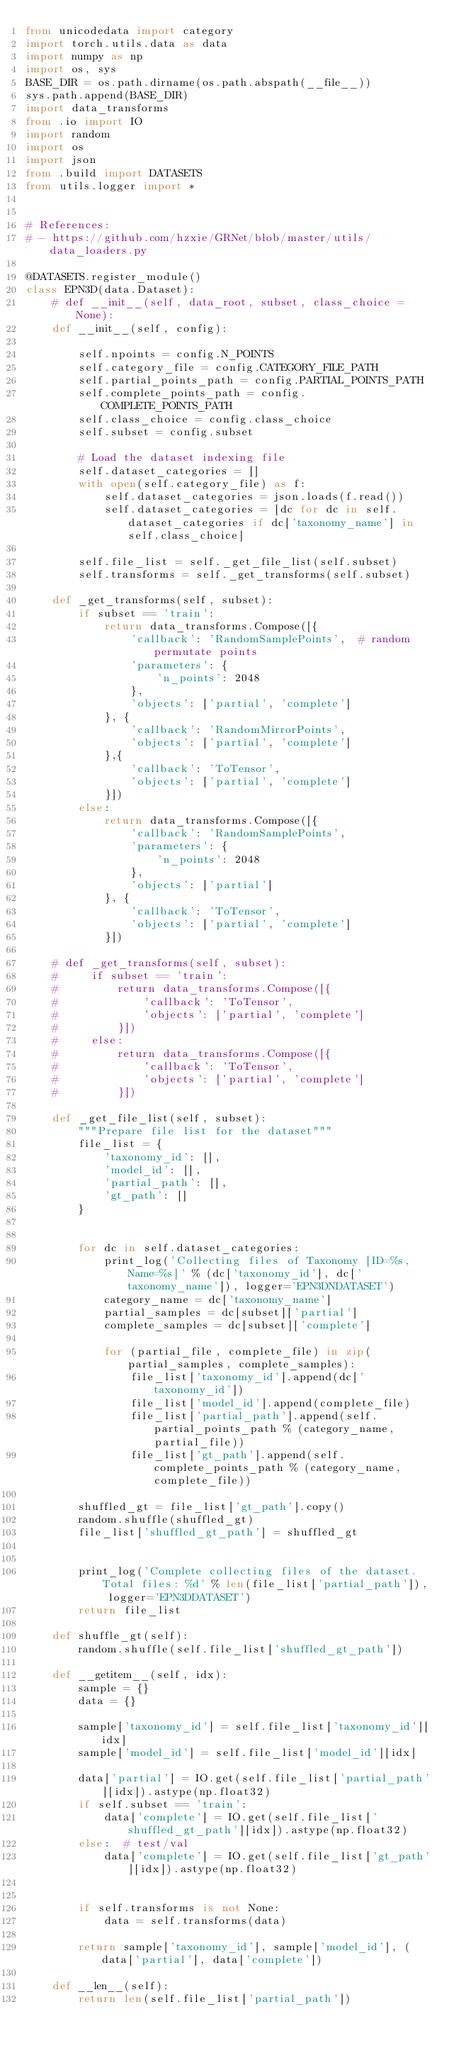Convert code to text. <code><loc_0><loc_0><loc_500><loc_500><_Python_>from unicodedata import category
import torch.utils.data as data
import numpy as np
import os, sys
BASE_DIR = os.path.dirname(os.path.abspath(__file__))
sys.path.append(BASE_DIR)
import data_transforms
from .io import IO
import random
import os
import json
from .build import DATASETS
from utils.logger import *


# References:
# - https://github.com/hzxie/GRNet/blob/master/utils/data_loaders.py

@DATASETS.register_module()
class EPN3D(data.Dataset):
    # def __init__(self, data_root, subset, class_choice = None):
    def __init__(self, config):

        self.npoints = config.N_POINTS
        self.category_file = config.CATEGORY_FILE_PATH
        self.partial_points_path = config.PARTIAL_POINTS_PATH
        self.complete_points_path = config.COMPLETE_POINTS_PATH
        self.class_choice = config.class_choice
        self.subset = config.subset

        # Load the dataset indexing file
        self.dataset_categories = []
        with open(self.category_file) as f:
            self.dataset_categories = json.loads(f.read())
            self.dataset_categories = [dc for dc in self.dataset_categories if dc['taxonomy_name'] in self.class_choice]

        self.file_list = self._get_file_list(self.subset)
        self.transforms = self._get_transforms(self.subset)

    def _get_transforms(self, subset):
        if subset == 'train':
            return data_transforms.Compose([{
                'callback': 'RandomSamplePoints',  # random permutate points
                'parameters': {
                    'n_points': 2048
                },
                'objects': ['partial', 'complete']
            }, {
                'callback': 'RandomMirrorPoints',
                'objects': ['partial', 'complete']
            },{
                'callback': 'ToTensor',
                'objects': ['partial', 'complete']
            }])
        else:
            return data_transforms.Compose([{
                'callback': 'RandomSamplePoints',
                'parameters': {
                    'n_points': 2048
                },
                'objects': ['partial']
            }, {
                'callback': 'ToTensor',
                'objects': ['partial', 'complete']
            }])

    # def _get_transforms(self, subset):
    #     if subset == 'train':
    #         return data_transforms.Compose([{
    #             'callback': 'ToTensor',
    #             'objects': ['partial', 'complete']
    #         }])
    #     else:
    #         return data_transforms.Compose([{
    #             'callback': 'ToTensor',
    #             'objects': ['partial', 'complete']
    #         }])

    def _get_file_list(self, subset):
        """Prepare file list for the dataset"""
        file_list = {
            'taxonomy_id': [],
            'model_id': [],
            'partial_path': [],
            'gt_path': []
        }


        for dc in self.dataset_categories:
            print_log('Collecting files of Taxonomy [ID=%s, Name=%s]' % (dc['taxonomy_id'], dc['taxonomy_name']), logger='EPN3DNDATASET')
            category_name = dc['taxonomy_name']
            partial_samples = dc[subset]['partial']
            complete_samples = dc[subset]['complete']

            for (partial_file, complete_file) in zip(partial_samples, complete_samples):
                file_list['taxonomy_id'].append(dc['taxonomy_id'])
                file_list['model_id'].append(complete_file)
                file_list['partial_path'].append(self.partial_points_path % (category_name, partial_file))
                file_list['gt_path'].append(self.complete_points_path % (category_name, complete_file))

        shuffled_gt = file_list['gt_path'].copy()
        random.shuffle(shuffled_gt)
        file_list['shuffled_gt_path'] = shuffled_gt


        print_log('Complete collecting files of the dataset. Total files: %d' % len(file_list['partial_path']), logger='EPN3DDATASET')
        return file_list

    def shuffle_gt(self):
        random.shuffle(self.file_list['shuffled_gt_path'])

    def __getitem__(self, idx):
        sample = {}
        data = {}

        sample['taxonomy_id'] = self.file_list['taxonomy_id'][idx]
        sample['model_id'] = self.file_list['model_id'][idx]

        data['partial'] = IO.get(self.file_list['partial_path'][idx]).astype(np.float32)
        if self.subset == 'train':
            data['complete'] = IO.get(self.file_list['shuffled_gt_path'][idx]).astype(np.float32)
        else:  # test/val
            data['complete'] = IO.get(self.file_list['gt_path'][idx]).astype(np.float32)


        if self.transforms is not None:
            data = self.transforms(data)

        return sample['taxonomy_id'], sample['model_id'], (data['partial'], data['complete'])

    def __len__(self):
        return len(self.file_list['partial_path'])</code> 